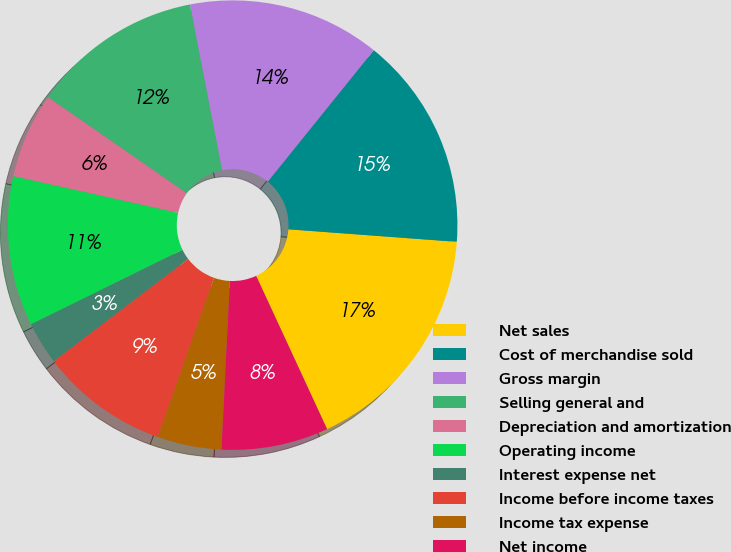<chart> <loc_0><loc_0><loc_500><loc_500><pie_chart><fcel>Net sales<fcel>Cost of merchandise sold<fcel>Gross margin<fcel>Selling general and<fcel>Depreciation and amortization<fcel>Operating income<fcel>Interest expense net<fcel>Income before income taxes<fcel>Income tax expense<fcel>Net income<nl><fcel>16.92%<fcel>15.38%<fcel>13.85%<fcel>12.31%<fcel>6.15%<fcel>10.77%<fcel>3.08%<fcel>9.23%<fcel>4.62%<fcel>7.69%<nl></chart> 